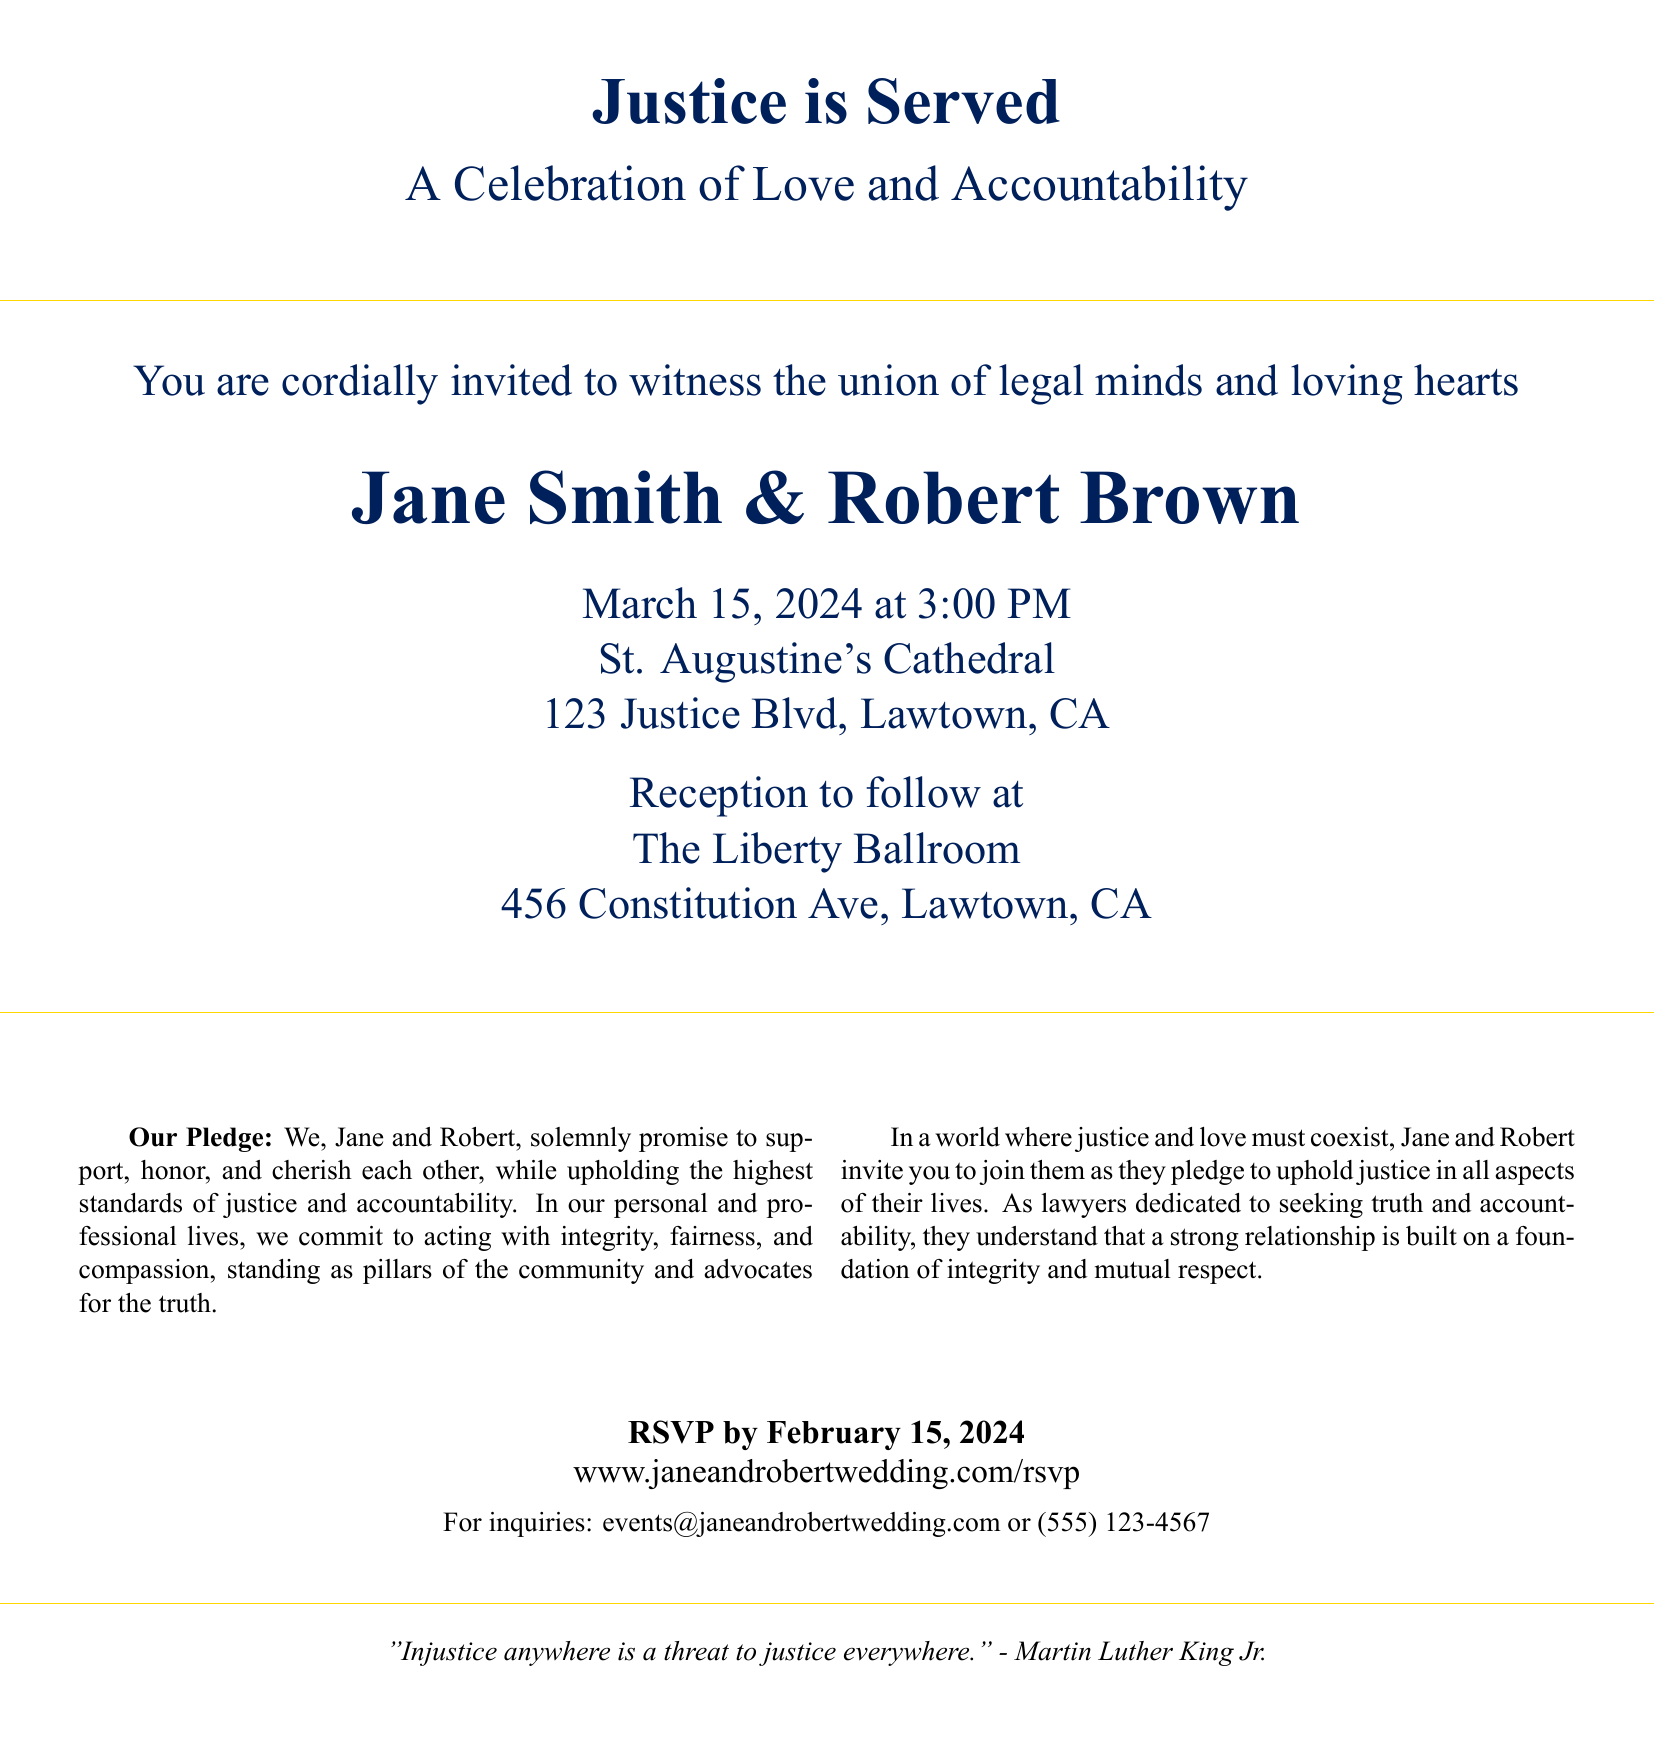What is the title of the event? The title of the event is prominently displayed at the top of the invitation, indicating the theme of the ceremony.
Answer: Justice is Served Who are the couple getting married? The names of the couple are highlighted in a larger font size for emphasis on the invitation.
Answer: Jane Smith & Robert Brown What is the date of the wedding ceremony? The date of the ceremony is clearly specified on the invitation, providing essential information to the guests.
Answer: March 15, 2024 Where will the ceremony take place? The venue of the ceremony is mentioned just below the date, detailing the location for the gathering.
Answer: St. Augustine's Cathedral What is included in the couple's pledge? The couple's pledge is a significant part of the invitation, outlining their commitment during the ceremony.
Answer: Support, honor, and cherish each other What time does the ceremony start? The starting time of the ceremony is explicitly stated to inform attendees when to arrive.
Answer: 3:00 PM What is the RSVP deadline? The RSVP deadline ensures that guests respond by a specific date, which is indicated on the invitation.
Answer: February 15, 2024 What is the theme of the couple's marriage? The theme reflects the couple's values and their professional background as lawyers, which is important for the invited guests to know.
Answer: Love and Accountability What is the significance of the quote included at the end of the invitation? The quote ties back to the overall theme of justice and is attributed to a renowned figure, connecting the event to a broader context.
Answer: Injustice anywhere is a threat to justice everywhere 